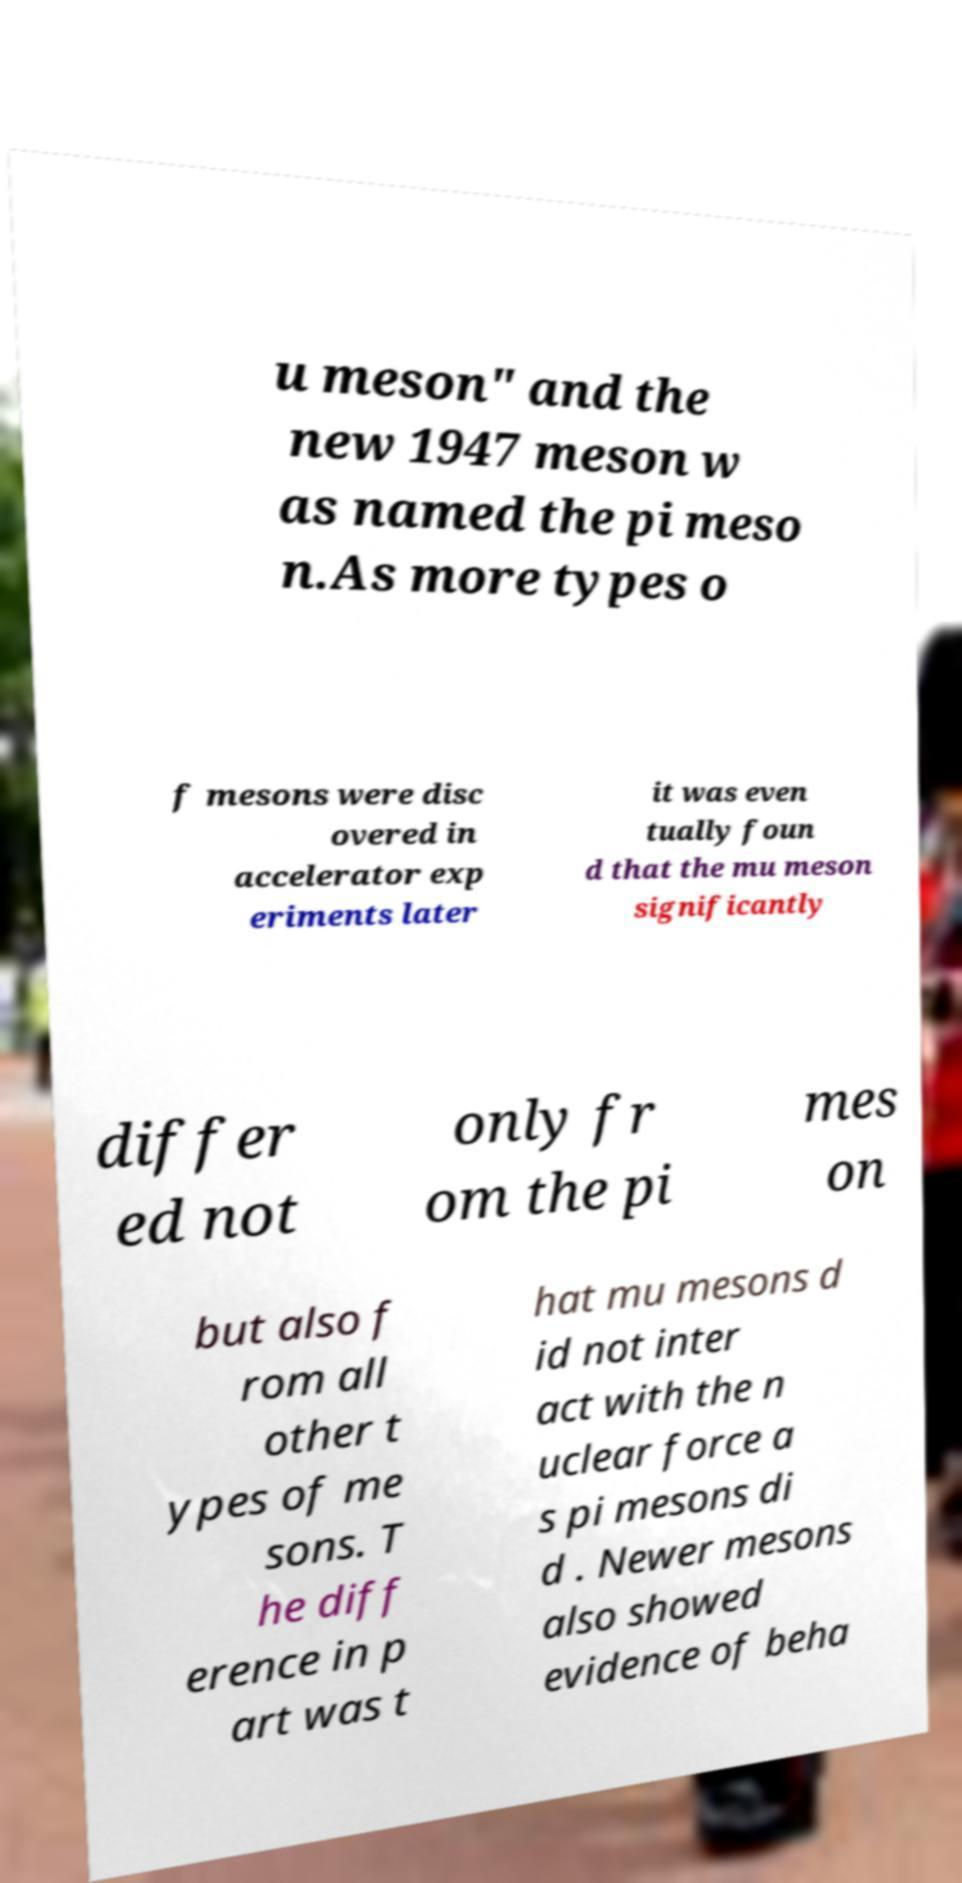Please read and relay the text visible in this image. What does it say? u meson" and the new 1947 meson w as named the pi meso n.As more types o f mesons were disc overed in accelerator exp eriments later it was even tually foun d that the mu meson significantly differ ed not only fr om the pi mes on but also f rom all other t ypes of me sons. T he diff erence in p art was t hat mu mesons d id not inter act with the n uclear force a s pi mesons di d . Newer mesons also showed evidence of beha 